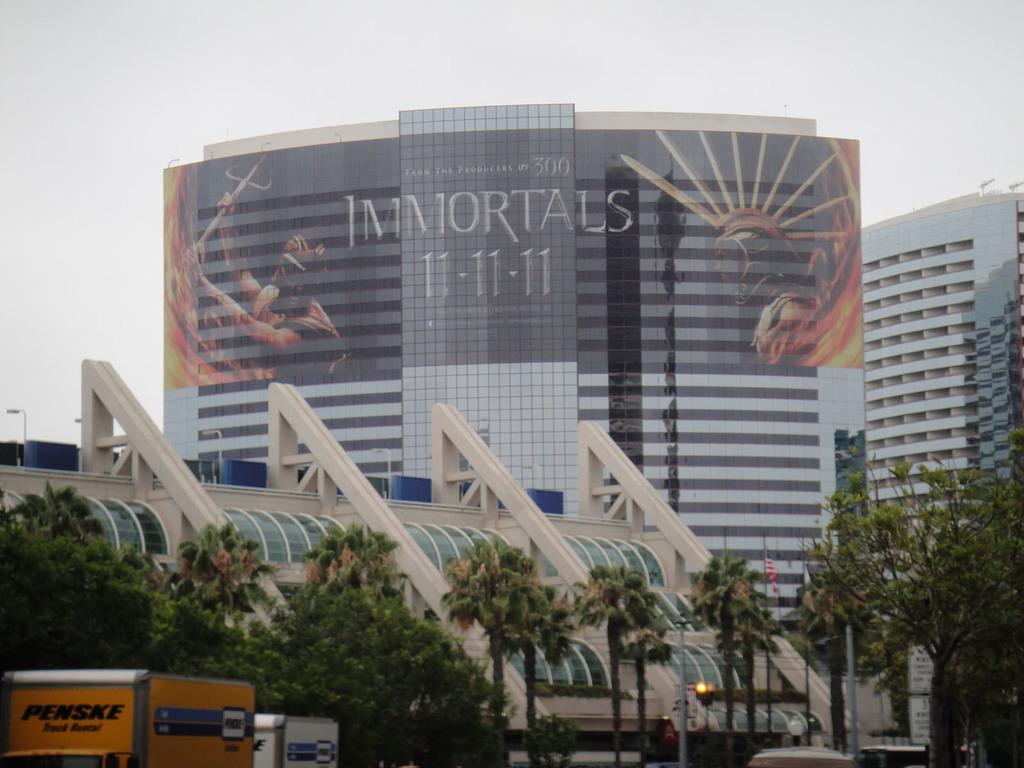In one or two sentences, can you explain what this image depicts? In this picture there are buildings and trees and there are poles and flags and there are vehicles. At the top there is sky and there is a text and there are pictures of the person on the building. 